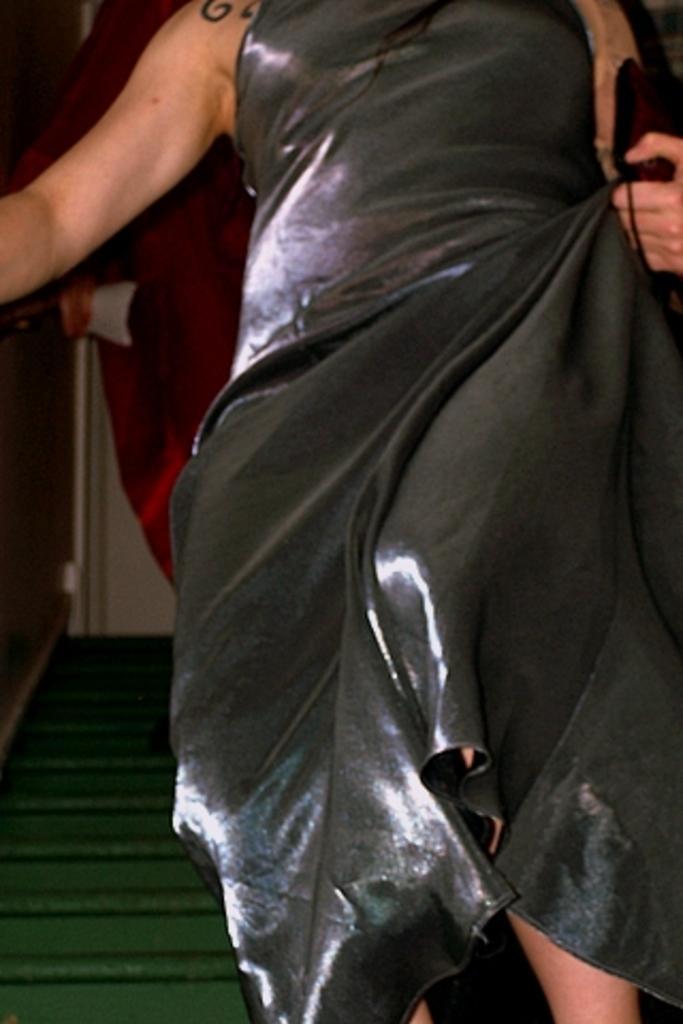Describe this image in one or two sentences. In this image we can see a lady. In the background there are stairs. 